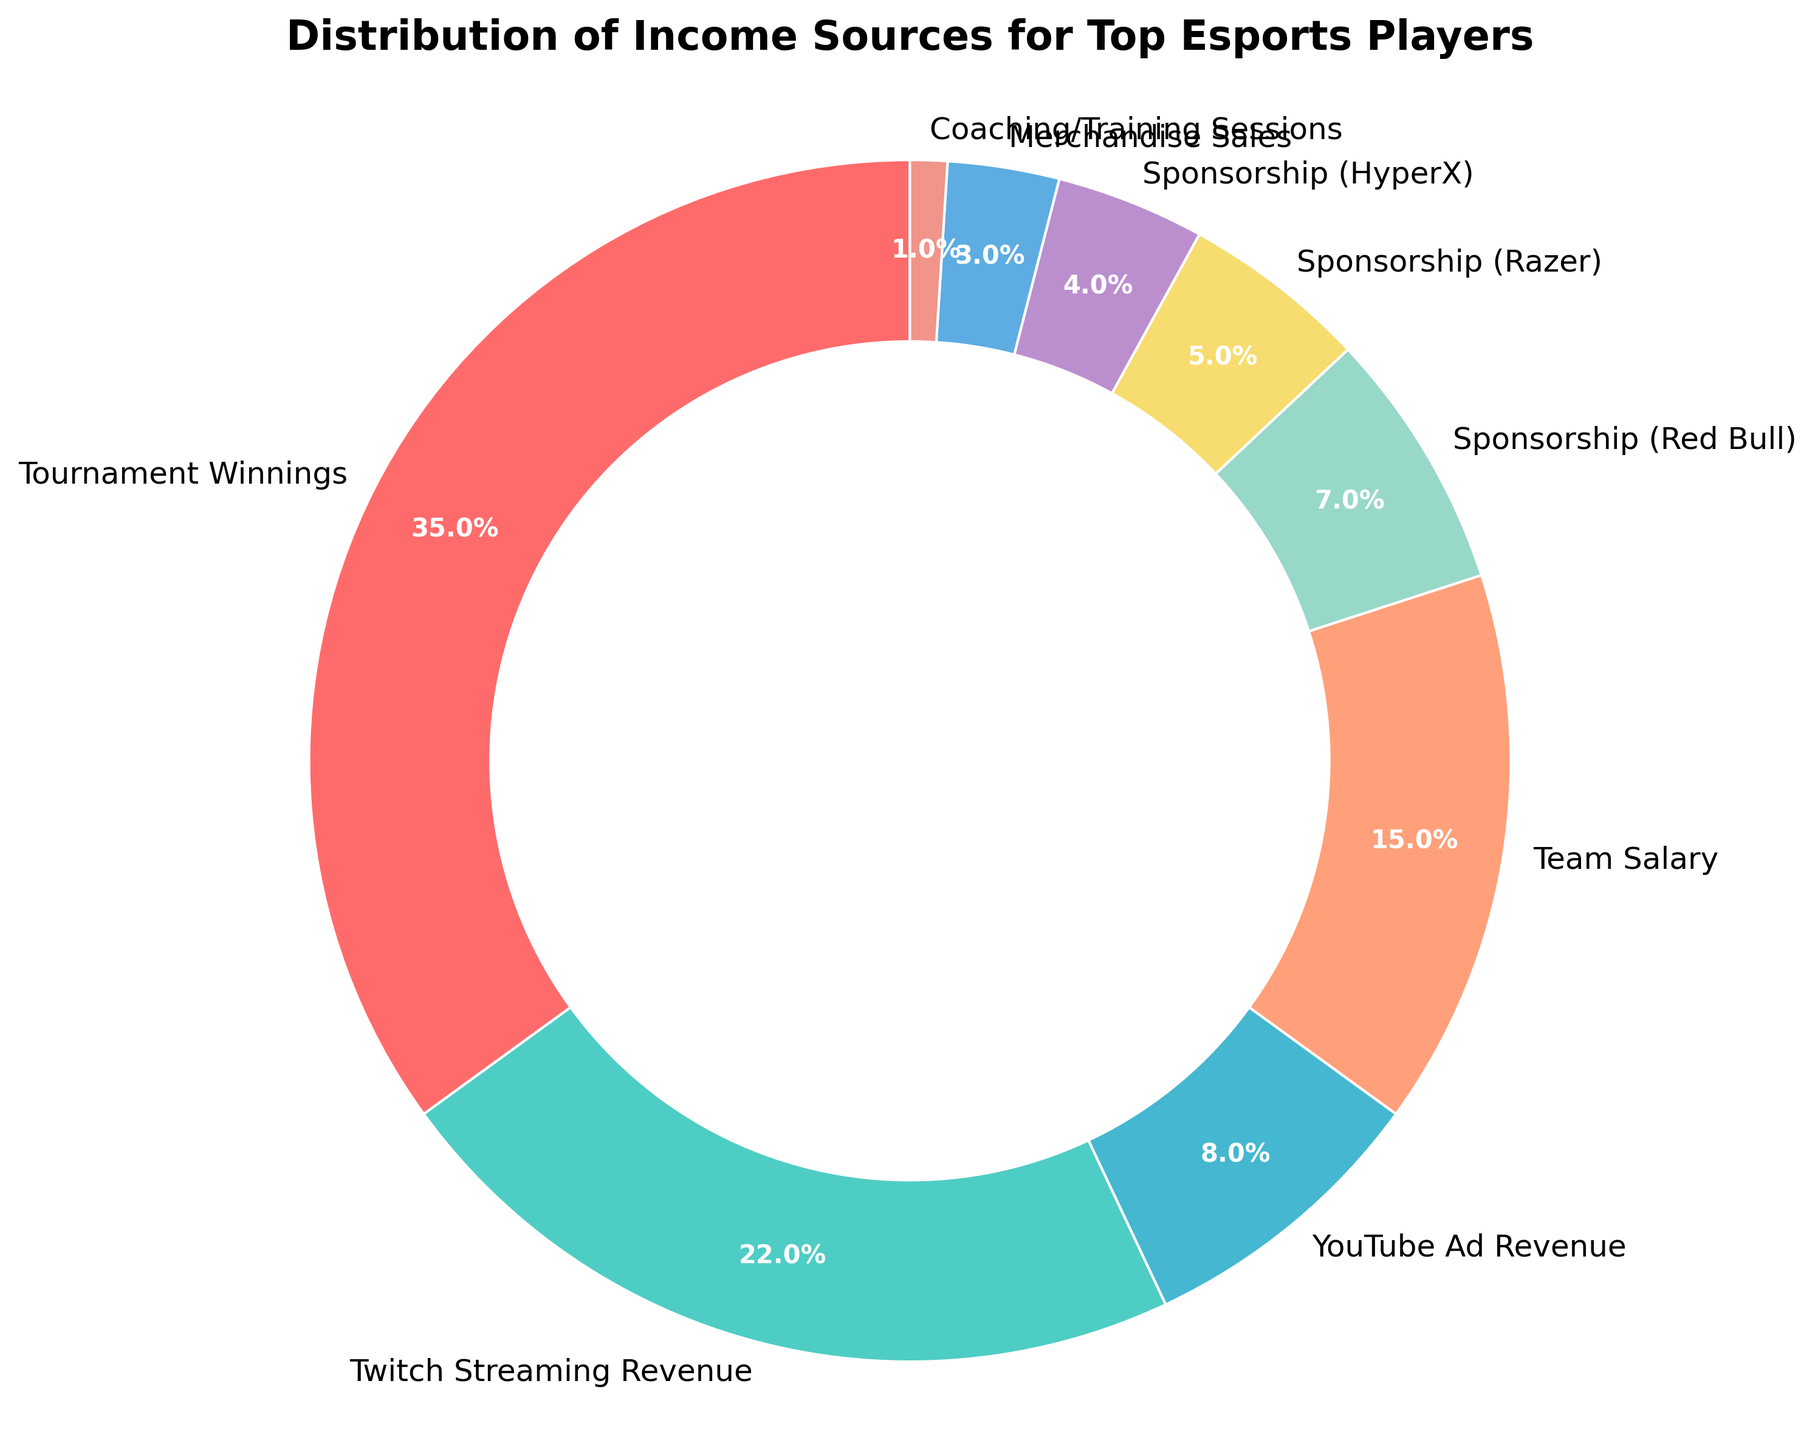What percentage of income comes from sponsorships in total? Sum the percentages of all sponsorships: 7% (Red Bull) + 5% (Razer) + 4% (HyperX) = 16%
Answer: 16% Which income source has the highest share? According to the pie chart, Tournament Winnings has the largest wedge, marked as 35%
Answer: Tournament Winnings Are streaming services (Twitch and YouTube) collectively contributing more income than Team Salary? Add the percentages of Twitch and YouTube: 22% + 8% = 30%, then compare with Team Salary at 15%. 30% is greater than 15%
Answer: Yes Which income source is marked with the most visually prominent color, and what is it? The largest wedge is Tournament Winnings and is highlighted with a bright red color, making it visually prominent
Answer: Tournament Winnings and red If sponsorships with Red Bull and Razer are merged into a single source, where would this merged source rank in terms of percentage compared to the others? Merging Red Bull and Razer sponsorships: 7% + 5% = 12%. Comparing this to other percentages: Tournament Winnings (35%), Twitch (22%), Team Salary (15%) are higher, and YouTube (8%) is lower. So it ranks fourth
Answer: Fourth What is the combined percentage of the three least contributing income sources? Identify the three smallest contributions: Coaching/Training Sessions (1%), Merchandise Sales (3%), Sponsorship (HyperX) (4%). Sum of these: 1% + 3% + 4% = 8%
Answer: 8% How much larger is the percentage of income from Tournament Winnings compared to Twitch Streaming Revenue? Subtract Twitch Streaming Revenue from Tournament Winnings: 35% - 22% = 13%
Answer: 13% Which sponsorship has the smallest contribution, and what percentage is it? According to the pie chart, Sponsorship (HyperX) has the smallest share among sponsorships with a 4% contribution
Answer: HyperX, 4% If the Team Salary percentage were to increase by 5%, what would the new percentage be and how would it compare to Twitch Streaming Revenue? Current percentage of Team Salary is 15%. Adding 5%, it becomes 15% + 5% = 20%. Compare with Twitch (22%): 20% is less than 22%
Answer: 20%, less than Twitch 